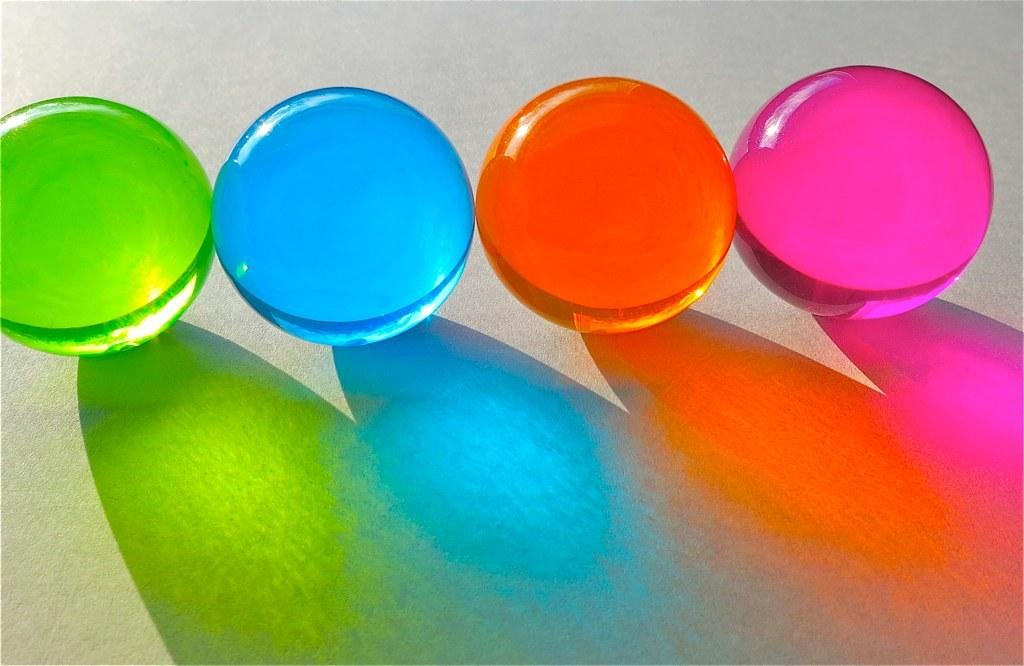How many balls are present in the image? There are four colored balls in the image. What can be observed about the positioning of the balls? The balls are on a surface. What type of flag is being used as a plate for the balls in the image? There is no flag or plate present in the image; the balls are simply on a surface. 